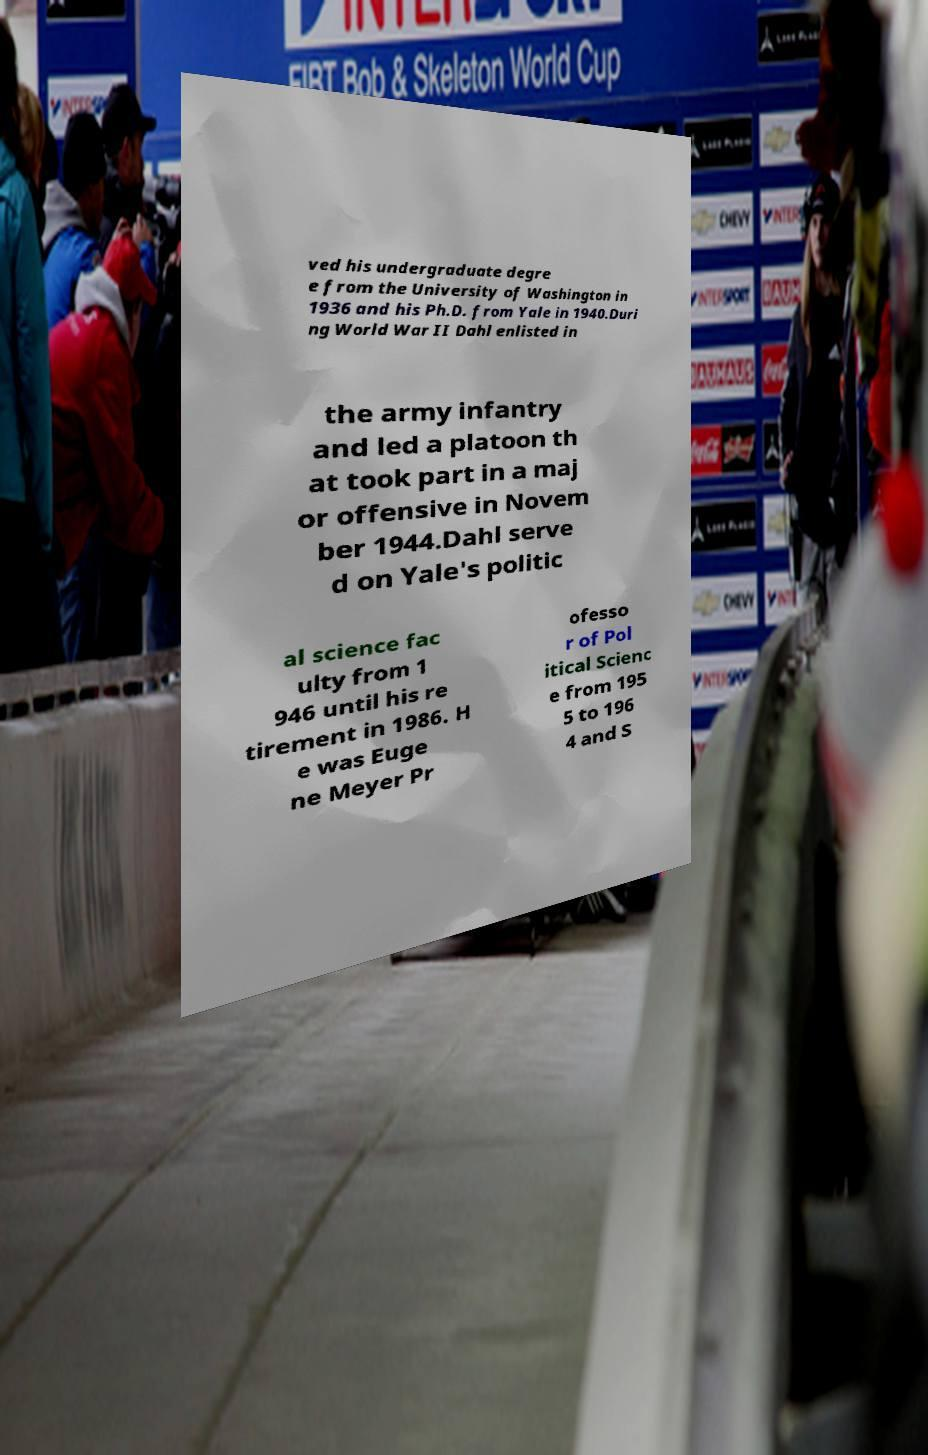Please read and relay the text visible in this image. What does it say? ved his undergraduate degre e from the University of Washington in 1936 and his Ph.D. from Yale in 1940.Duri ng World War II Dahl enlisted in the army infantry and led a platoon th at took part in a maj or offensive in Novem ber 1944.Dahl serve d on Yale's politic al science fac ulty from 1 946 until his re tirement in 1986. H e was Euge ne Meyer Pr ofesso r of Pol itical Scienc e from 195 5 to 196 4 and S 